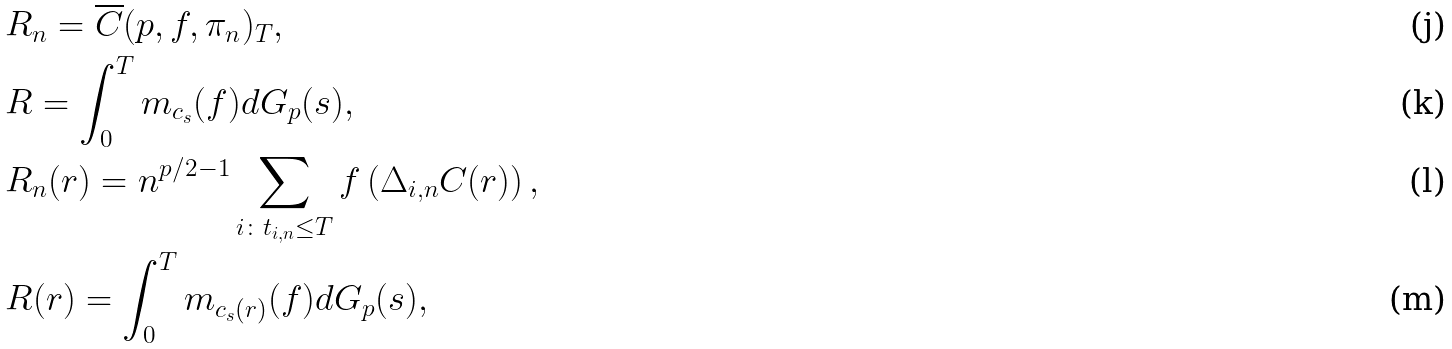Convert formula to latex. <formula><loc_0><loc_0><loc_500><loc_500>& R _ { n } = \overline { C } ( p , f , \pi _ { n } ) _ { T } , \\ & R = \int _ { 0 } ^ { T } m _ { c _ { s } } ( f ) d { G _ { p } } ( s ) , \\ & R _ { n } ( r ) = n ^ { p / 2 - 1 } \sum _ { i \colon t _ { i , n } \leq T } f \left ( \Delta _ { i , n } C ( r ) \right ) , \\ & R ( r ) = \int _ { 0 } ^ { T } m _ { c _ { s } ( r ) } ( f ) d { G _ { p } } ( s ) ,</formula> 